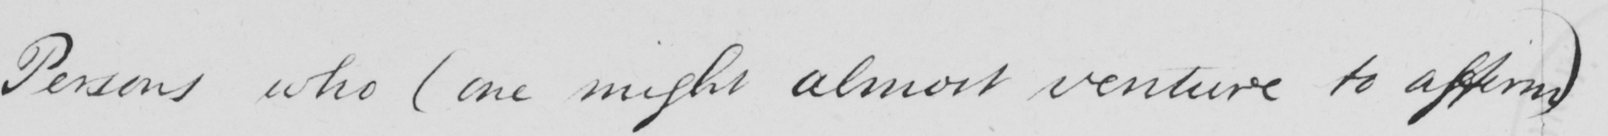What is written in this line of handwriting? Persons who  ( one might almost venture to affirm ) 